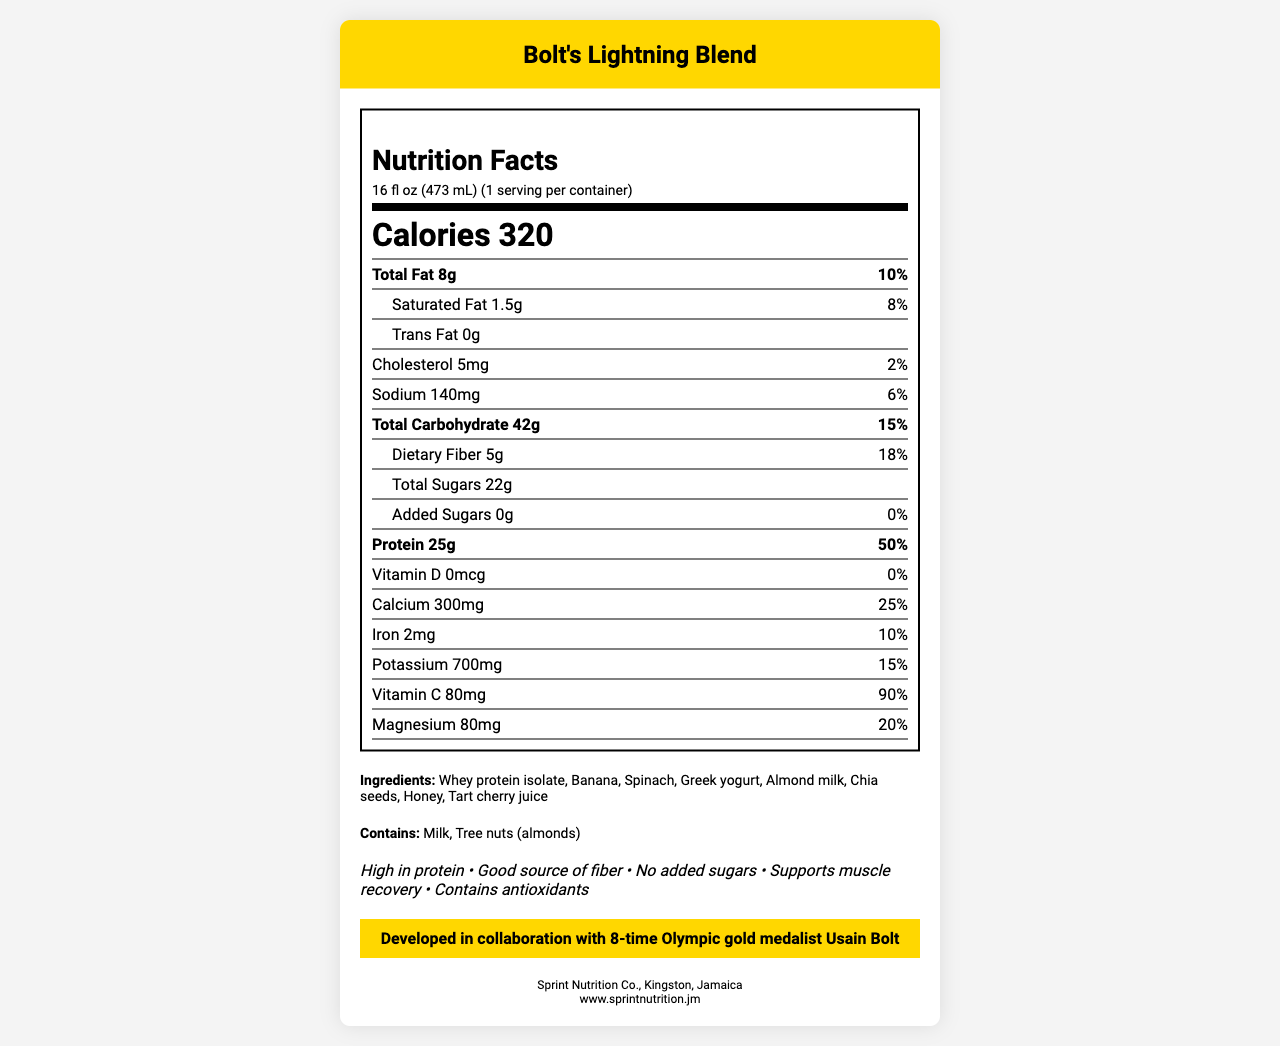How many calories are in one serving of Bolt's Lightning Blend? The label lists the number of calories per serving as 320.
Answer: 320 What is the amount of protein per serving? The document states that the protein amount per serving is 25g.
Answer: 25g What percentage of the daily value of calcium does Bolt's Lightning Blend provide? The label indicates that the calcium content is 300mg, which is 25% of the daily value.
Answer: 25% What are the main ingredients in Bolt's Lightning Blend? The ingredients are listed in the section labeled "Ingredients."
Answer: Whey protein isolate, Banana, Spinach, Greek yogurt, Almond milk, Chia seeds, Honey, Tart cherry juice Which allergens are present in Bolt's Lightning Blend? The allergens listed are Milk and Tree nuts (almonds).
Answer: Milk, Tree nuts (almonds) How much sodium is in one serving? The document states that the sodium content per serving is 140mg.
Answer: 140mg Which of the following vitamins is present in the highest percentage of the daily value in Bolt's Lightning Blend? A. Vitamin D B. Calcium C. Vitamin C D. Iron The label shows Vitamin D at 0%, Calcium at 25%, Vitamin C at 90%, and Iron at 10%. Vitamin C is present in the highest percentage of the daily value.
Answer: C. Vitamin C How much dietary fiber does one serving of Bolt's Lightning Blend contain? A. 3g B. 5g C. 8g D. 10g The label indicates that the dietary fiber content per serving is 5g.
Answer: B. 5g Does Bolt's Lightning Blend contain any added sugars? The document states that the amount of added sugars is 0g.
Answer: No Has Bolt's Lightning Blend been endorsed by any athlete? The endorsement section states it was developed in collaboration with 8-time Olympic gold medalist Usain Bolt.
Answer: Yes Summarize the main nutritional benefits of Bolt's Lightning Blend. The claims section highlights these main benefits, indicating it is designed as a protein-rich and nutritious post-workout option.
Answer: High in protein, good source of fiber, no added sugars, supports muscle recovery, contains antioxidants Does Bolt's Lightning Blend contain any trans fats? The label clearly states that the product contains 0g of trans fats.
Answer: No Where is the manufacturer of Bolt's Lightning Blend located? The manufacturer's address is provided at the end of the document.
Answer: Kingston, Jamaica How many grams of total sugars are in one serving? The label lists the total sugars content as 22g per serving.
Answer: 22g What is the daily value percentage of magnesium provided in one serving? The label indicates that the magnesium content is 80mg, which is 20% of the daily value.
Answer: 20% How many servings are there in a container of Bolt's Lightning Blend? The label states that there is 1 serving per container.
Answer: 1 What is the website of the manufacturer of Bolt's Lightning Blend? The manufacturer's website is provided at the end of the document.
Answer: www.sprintnutrition.jm What are the benefits mentioned for Bolt's Lightning Blend? The benefits are listed in the claims section of the document.
Answer: High in protein, good source of fiber, no added sugars, supports muscle recovery, contains antioxidants Who is the intended collaborator for the development of Bolt's Lightning Blend? The document states that it was developed in collaboration with 8-time Olympic gold medalist Usain Bolt.
Answer: Usain Bolt What is the percentage of the daily value of iron provided by Bolt's Lightning Blend? The label indicates that the iron content is 2mg, which is 10% of the daily value.
Answer: 10% Who distributes Bolt's Lightning Blend? The document provides manufacturing information but no details about distribution.
Answer: Not enough information 